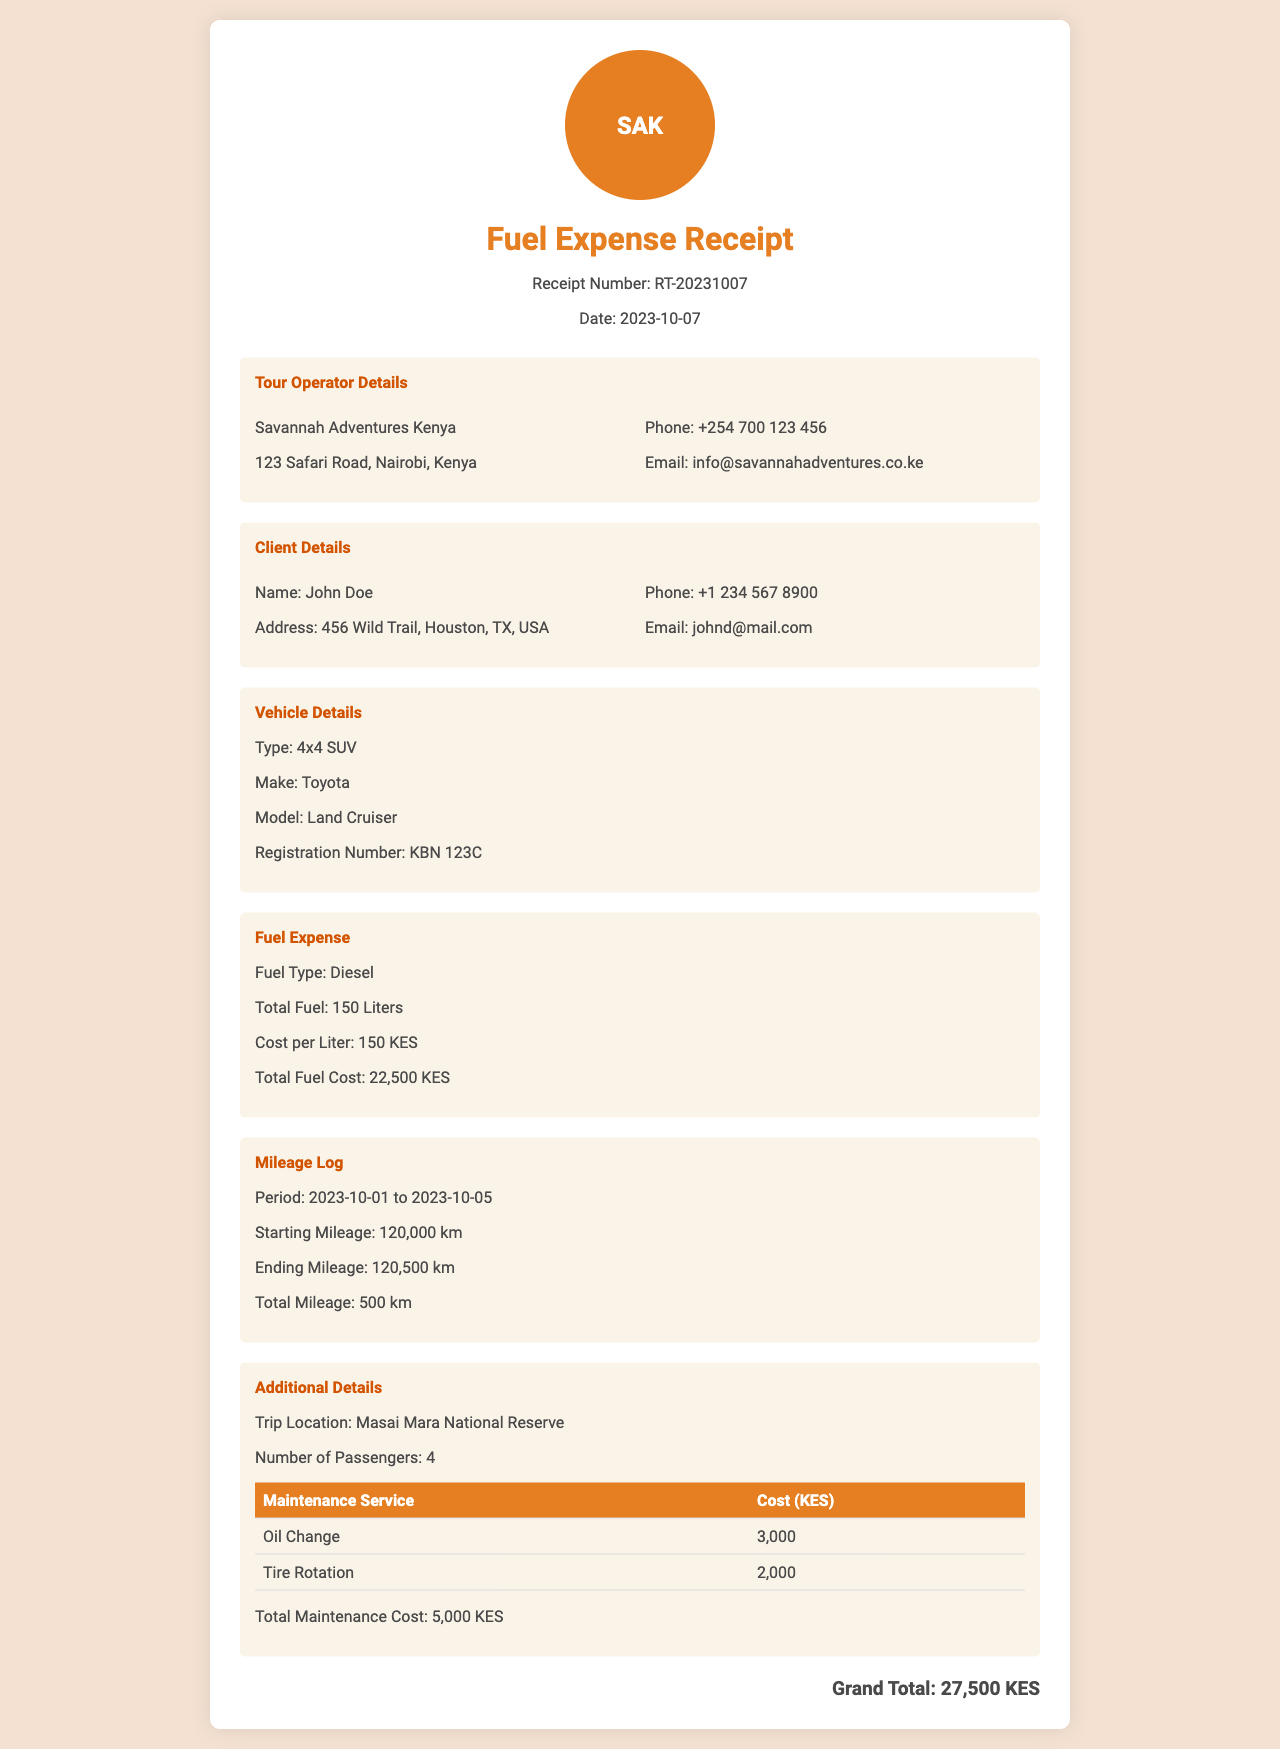what is the receipt number? The receipt number is mentioned in the document as a unique identifier for this transaction.
Answer: RT-20231007 what is the total fuel cost? The total fuel cost is provided in the fuel expense section as the total amount spent on fuel.
Answer: 22,500 KES who is the client? The client details section provides the name of the client who received the service.
Answer: John Doe what is the total mileage recorded? The total mileage is calculated based on the starting and ending mileage and is stated in the mileage log section.
Answer: 500 km what type of fuel was used? The type of fuel is specified in the fuel expense section of the document.
Answer: Diesel how many passengers were on the trip? The number of passengers is indicated in the additional details section of the document.
Answer: 4 what is the make of the vehicle? The vehicle details section specifies the make of the vehicle used during the safari trip.
Answer: Toyota what is the cost of oil change maintenance? The cost of maintenance services includes different entries, one of which is the oil change cost.
Answer: 3,000 what is the trip location? The trip location is detailed in the additional details section, indicating where the safari took place.
Answer: Masai Mara National Reserve what is the grand total amount? The grand total amount in the document sums all the expenses related to fuel and maintenance.
Answer: 27,500 KES 